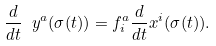<formula> <loc_0><loc_0><loc_500><loc_500>\frac { d } { d t } \ y ^ { a } ( \sigma ( t ) ) = f ^ { a } _ { i } \frac { d } { d t } x ^ { i } ( \sigma ( t ) ) .</formula> 